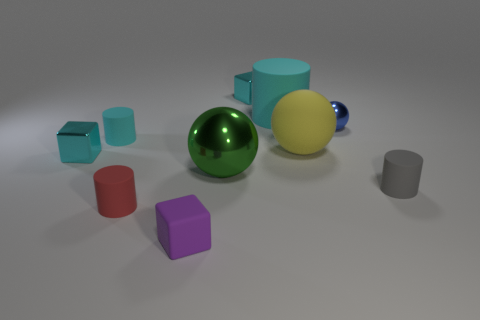Subtract all cyan cylinders. How many were subtracted if there are1cyan cylinders left? 1 Subtract all balls. How many objects are left? 7 Subtract 3 cylinders. How many cylinders are left? 1 Subtract all red spheres. Subtract all cyan cylinders. How many spheres are left? 3 Subtract all purple cubes. How many purple cylinders are left? 0 Subtract all tiny blue metal spheres. Subtract all large balls. How many objects are left? 7 Add 2 rubber blocks. How many rubber blocks are left? 3 Add 4 cyan rubber things. How many cyan rubber things exist? 6 Subtract all gray cylinders. How many cylinders are left? 3 Subtract all cyan cubes. How many cubes are left? 1 